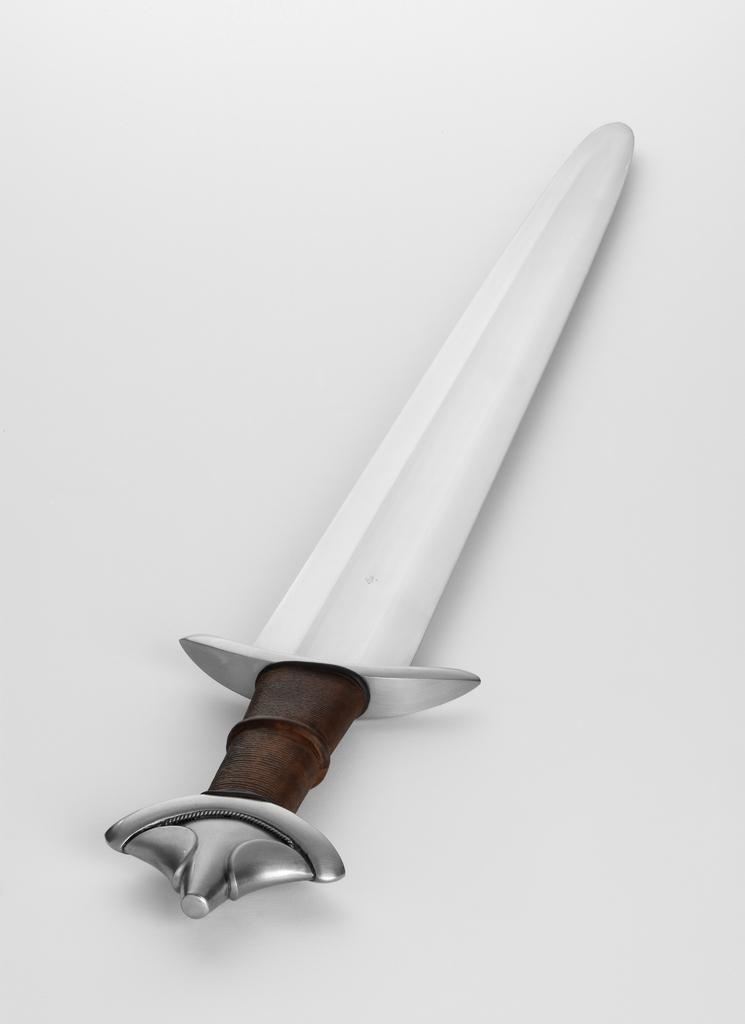What object can be seen in the image? There is a knife in the image. What color is the background of the image? The background of the image is white. How many farmers are present in the image? There are no farmers present in the image; it only features a knife and a white background. What type of line can be seen in the image? There is no line present in the image; it only features a knife and a white background. 